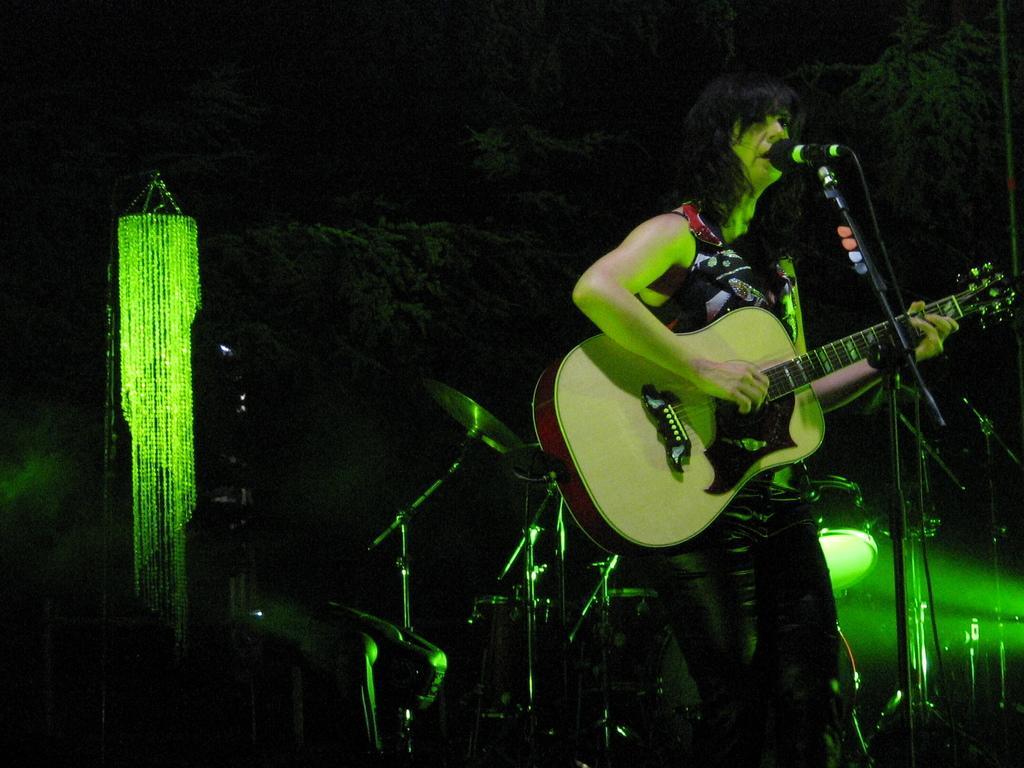Please provide a concise description of this image. this picture shows a woman Standing and playing a guitar by holding in her hand and we see a microphone in front of her 